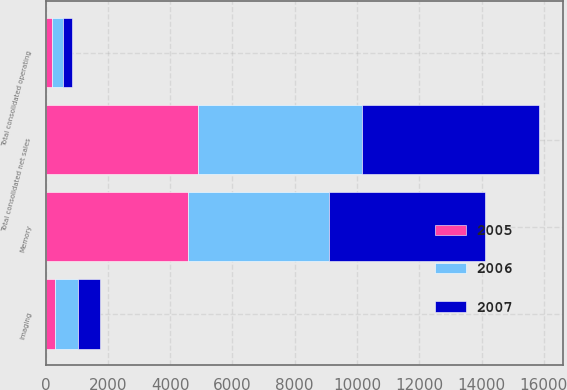Convert chart. <chart><loc_0><loc_0><loc_500><loc_500><stacked_bar_chart><ecel><fcel>Memory<fcel>Imaging<fcel>Total consolidated net sales<fcel>Total consolidated operating<nl><fcel>2007<fcel>5001<fcel>687<fcel>5688<fcel>280<nl><fcel>2006<fcel>4523<fcel>749<fcel>5272<fcel>350<nl><fcel>2005<fcel>4577<fcel>303<fcel>4880<fcel>217<nl></chart> 